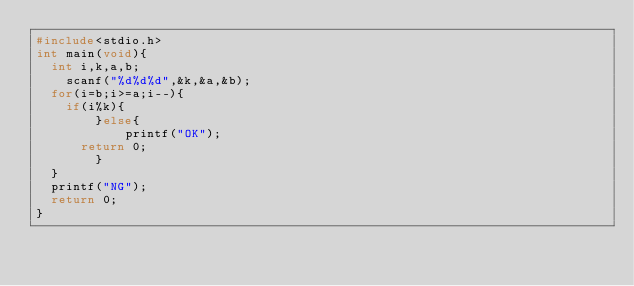<code> <loc_0><loc_0><loc_500><loc_500><_C_>#include<stdio.h>
int main(void){
	int i,k,a,b;
    scanf("%d%d%d",&k,&a,&b);
	for(i=b;i>=a;i--){
		if(i%k){
        }else{
            printf("OK");
			return 0;
        }
	}
	printf("NG");
	return 0;
}</code> 